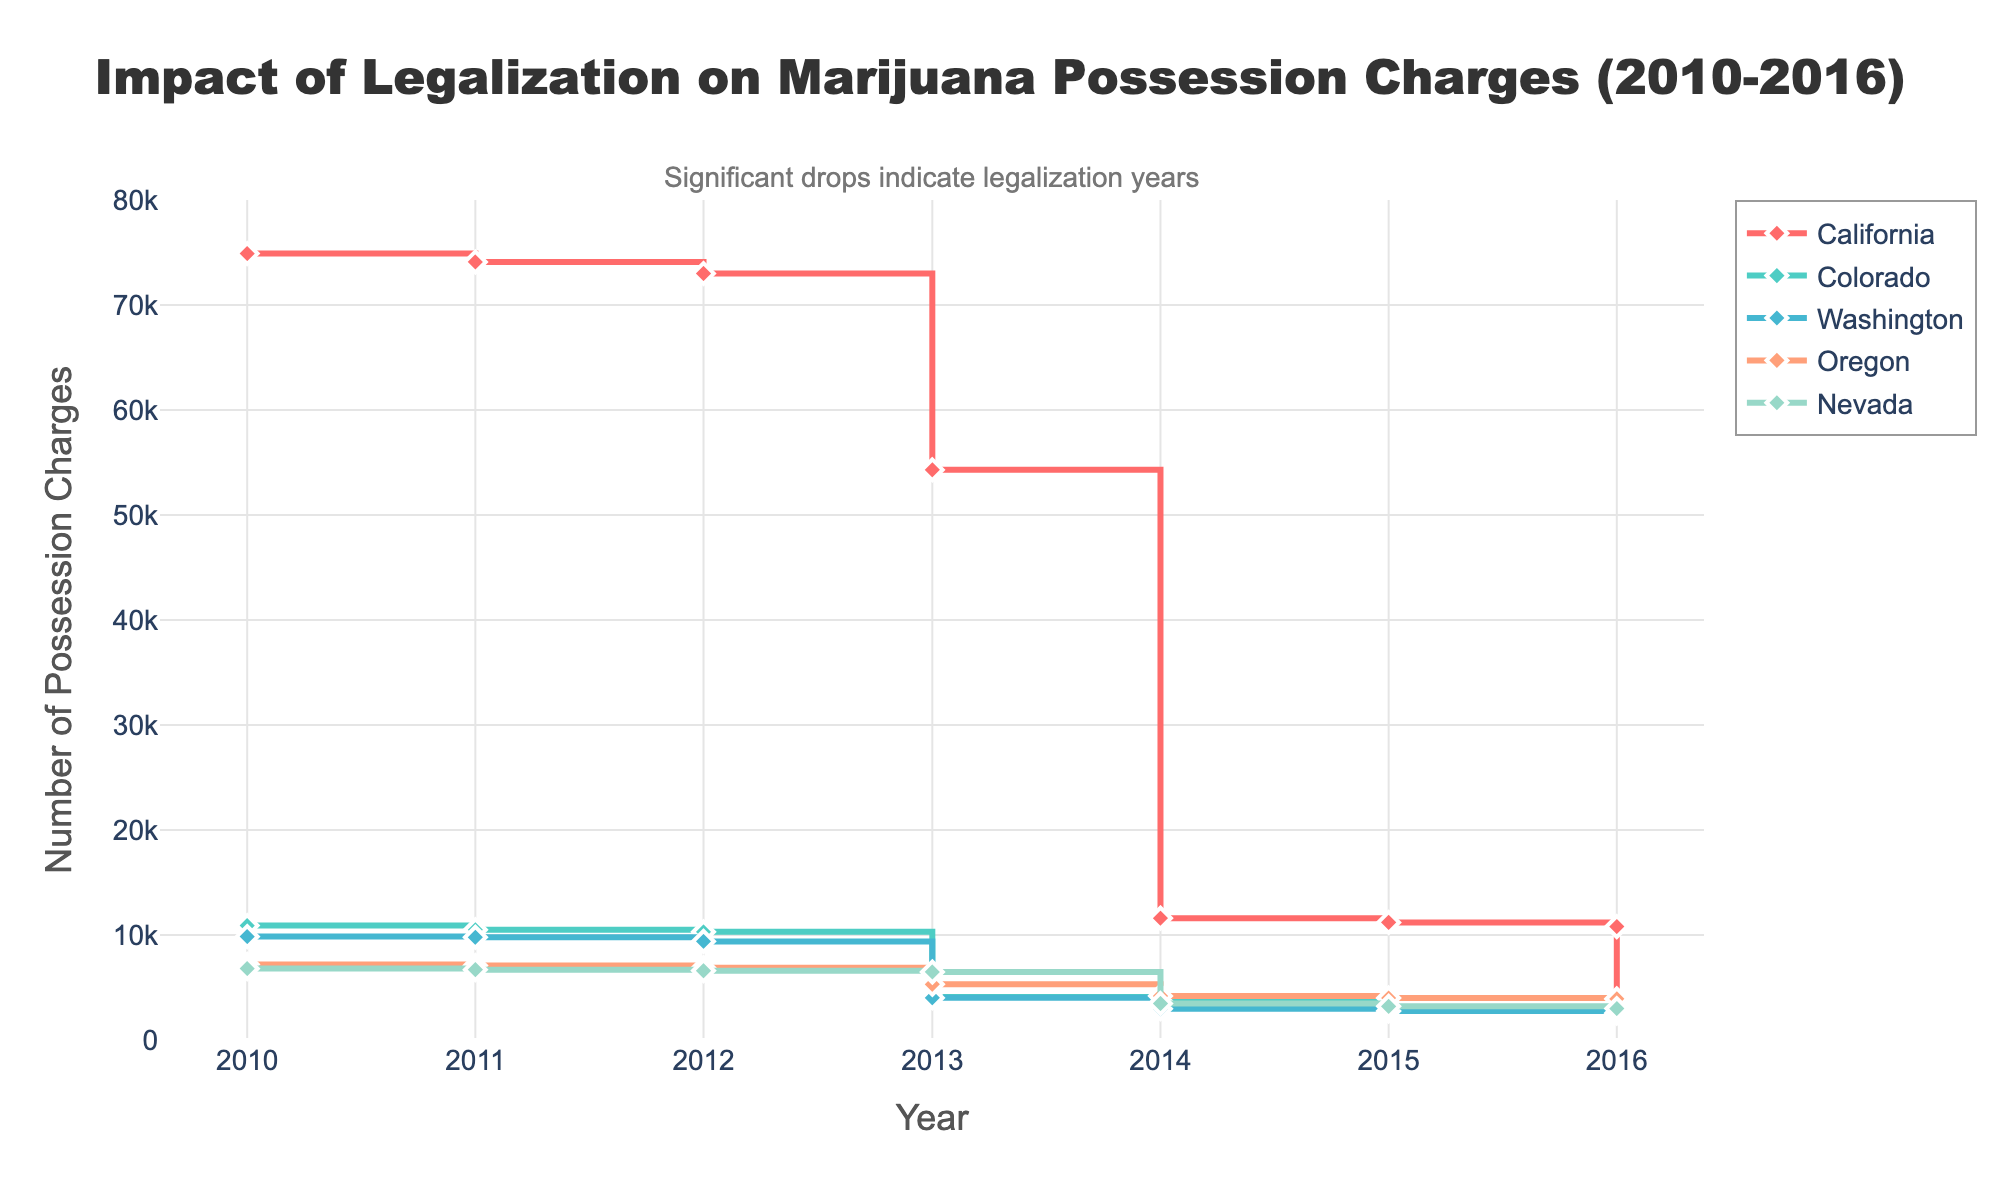How does the number of marijuana possession charges in California change from 2010 to 2016? Observing the line for California in the plot, we see a sharp decline from 74,900 in 2010 to 10,800 in 2016. The most significant drop happens between 2013 and 2014.
Answer: It decreases from 74,900 to 10,800 What year shows the most significant decrease in marijuana possession charges in Colorado? Looking at the line for Colorado, the most significant drop occurs between 2012 and 2013 when the charges fall from around 10,300 to approximately 4,090.
Answer: 2013 Which state had the highest number of possession charges in 2010, and what was that number? By observing the plot for the year 2010, California had the highest number of possession charges with 74,900.
Answer: California, 74,900 Compare the number of possession charges in Washington between 2012 and 2014. What do you observe? In 2012, Washington had 9,391 possession charges, and this number dropped to 2,980 in 2014, showing a significant decrease.
Answer: A significant decrease How do marijuana possession charges in Oregon trend from 2014 to 2016? According to the plot, Oregon's charges decrease modestly from 4,190 in 2014 to 3,921 in 2016.
Answer: Modest decrease In which year did Nevada experience its greatest drop in marijuana possession charges, and how large was this drop? Nevada's greatest drop happens between 2013 and 2014 when the number of charges falls from 6,480 to 3,480, which is a decrease of 3,000 charges.
Answer: 2014, 3,000 charges Which state had the lowest number of possession charges in 2016, and what was that number? In 2016, the state with the lowest number of charges is Washington, with 2,559 possession charges.
Answer: Washington, 2,559 What can be inferred about the impact of marijuana legalization on possession charges based on the trends shown in the plot? The plot shows significant declines in possession charges following the years when marijuana legalization happened in the respective states, indicating that legalization had a substantial impact on reducing these charges.
Answer: Significant impact, reduced charges What is the color associated with California's data in the plot, and why is this important for interpretation? California's line is represented by a red color (#FF6B6B), which helps in distinguishing its data trend from other states in the plot.
Answer: Red color 